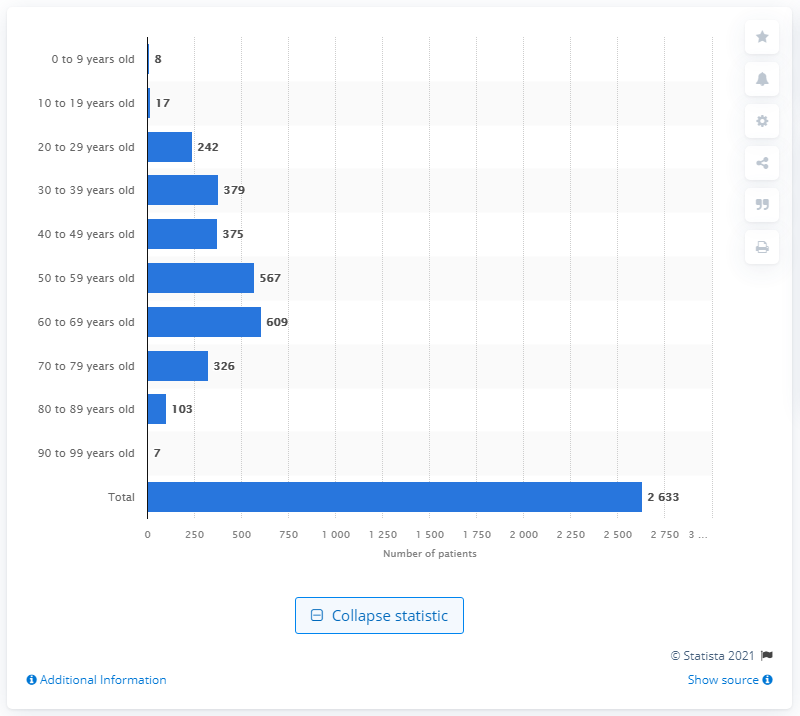Give some essential details in this illustration. As of April 2, 2020, a total of 609 patients in the Philippines have been diagnosed with COVID-19, a coronavirus disease. 